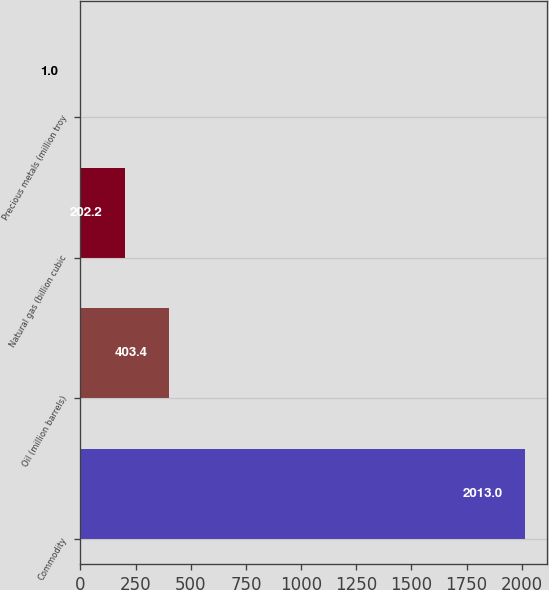<chart> <loc_0><loc_0><loc_500><loc_500><bar_chart><fcel>Commodity<fcel>Oil (million barrels)<fcel>Natural gas (billion cubic<fcel>Precious metals (million troy<nl><fcel>2013<fcel>403.4<fcel>202.2<fcel>1<nl></chart> 